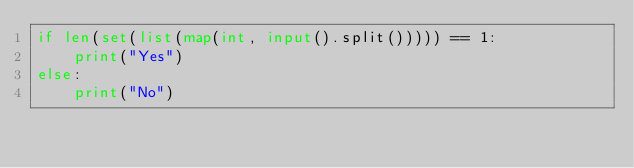Convert code to text. <code><loc_0><loc_0><loc_500><loc_500><_Python_>if len(set(list(map(int, input().split())))) == 1:
    print("Yes")
else:
    print("No")
</code> 